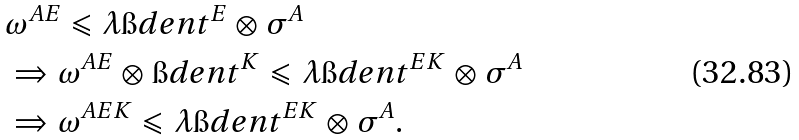<formula> <loc_0><loc_0><loc_500><loc_500>& \omega ^ { A E } \leqslant \lambda \i d e n t ^ { E } \otimes \sigma ^ { A } \\ & \Rightarrow \omega ^ { A E } \otimes \i d e n t ^ { K } \leqslant \lambda \i d e n t ^ { E K } \otimes \sigma ^ { A } \\ & \Rightarrow \omega ^ { A E K } \leqslant \lambda \i d e n t ^ { E K } \otimes \sigma ^ { A } .</formula> 